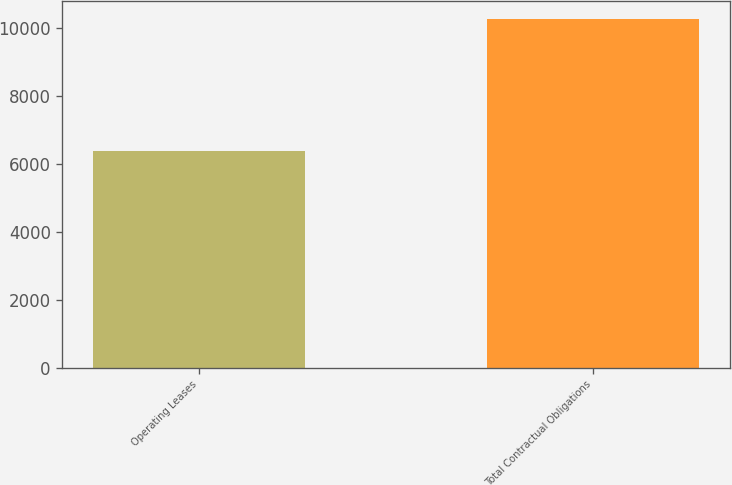Convert chart to OTSL. <chart><loc_0><loc_0><loc_500><loc_500><bar_chart><fcel>Operating Leases<fcel>Total Contractual Obligations<nl><fcel>6365<fcel>10260<nl></chart> 